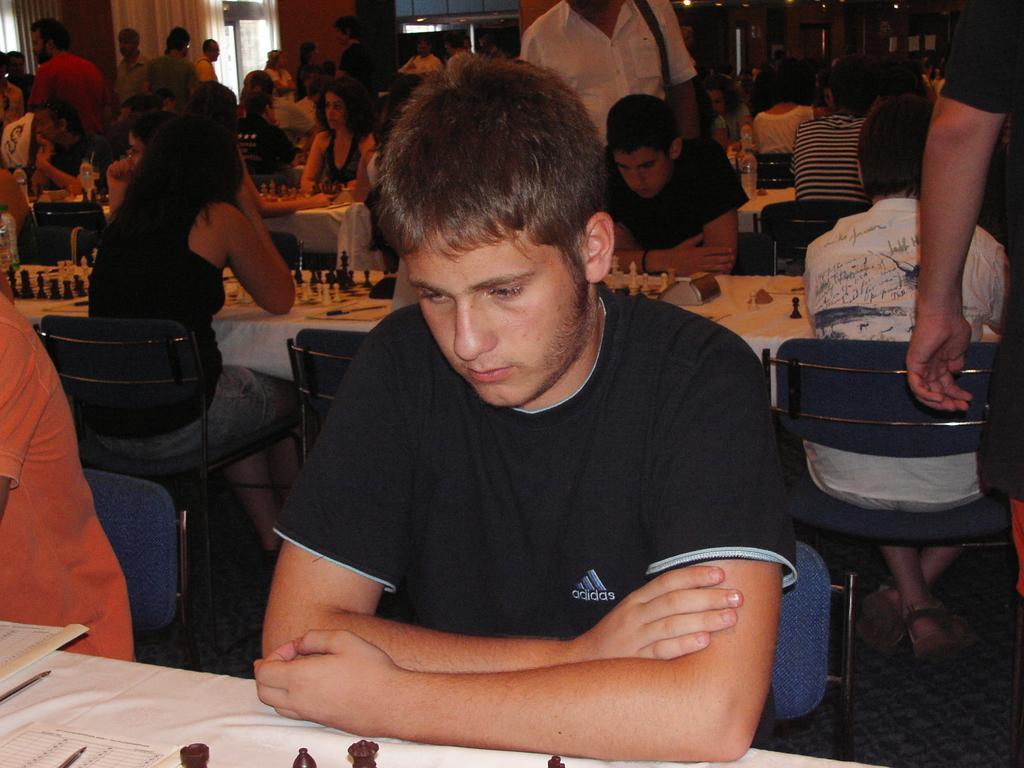How would you summarize this image in a sentence or two? This picture is inside of the room. There are group of people sitting behind the table. There are chess boards, bottles, paper, pen on the table. The table is covered with white color cloth. 